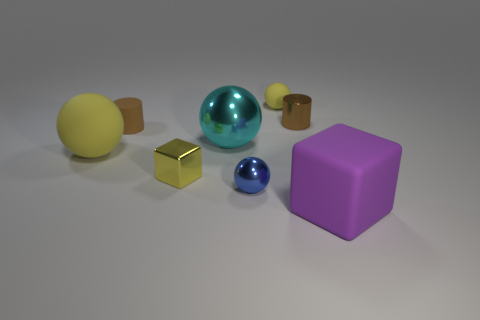There is another metal thing that is the same shape as the big cyan shiny object; what size is it?
Ensure brevity in your answer.  Small. Is there another blue sphere that has the same size as the blue metallic ball?
Your response must be concise. No. Is the color of the tiny shiny cylinder the same as the small thing that is on the left side of the yellow shiny object?
Your response must be concise. Yes. There is a yellow rubber thing that is on the left side of the metal block; how many large shiny balls are behind it?
Provide a succinct answer. 1. What color is the block left of the rubber object to the right of the brown metallic cylinder?
Your response must be concise. Yellow. There is a thing that is both in front of the brown metallic thing and right of the small yellow ball; what is its material?
Your response must be concise. Rubber. Is there a small yellow object that has the same shape as the large purple object?
Make the answer very short. Yes. Does the small metallic object on the right side of the small yellow matte object have the same shape as the large yellow object?
Ensure brevity in your answer.  No. What number of tiny shiny objects are both left of the small brown metallic cylinder and behind the tiny metal sphere?
Give a very brief answer. 1. There is a yellow metal object in front of the big yellow sphere; what is its shape?
Provide a short and direct response. Cube. 